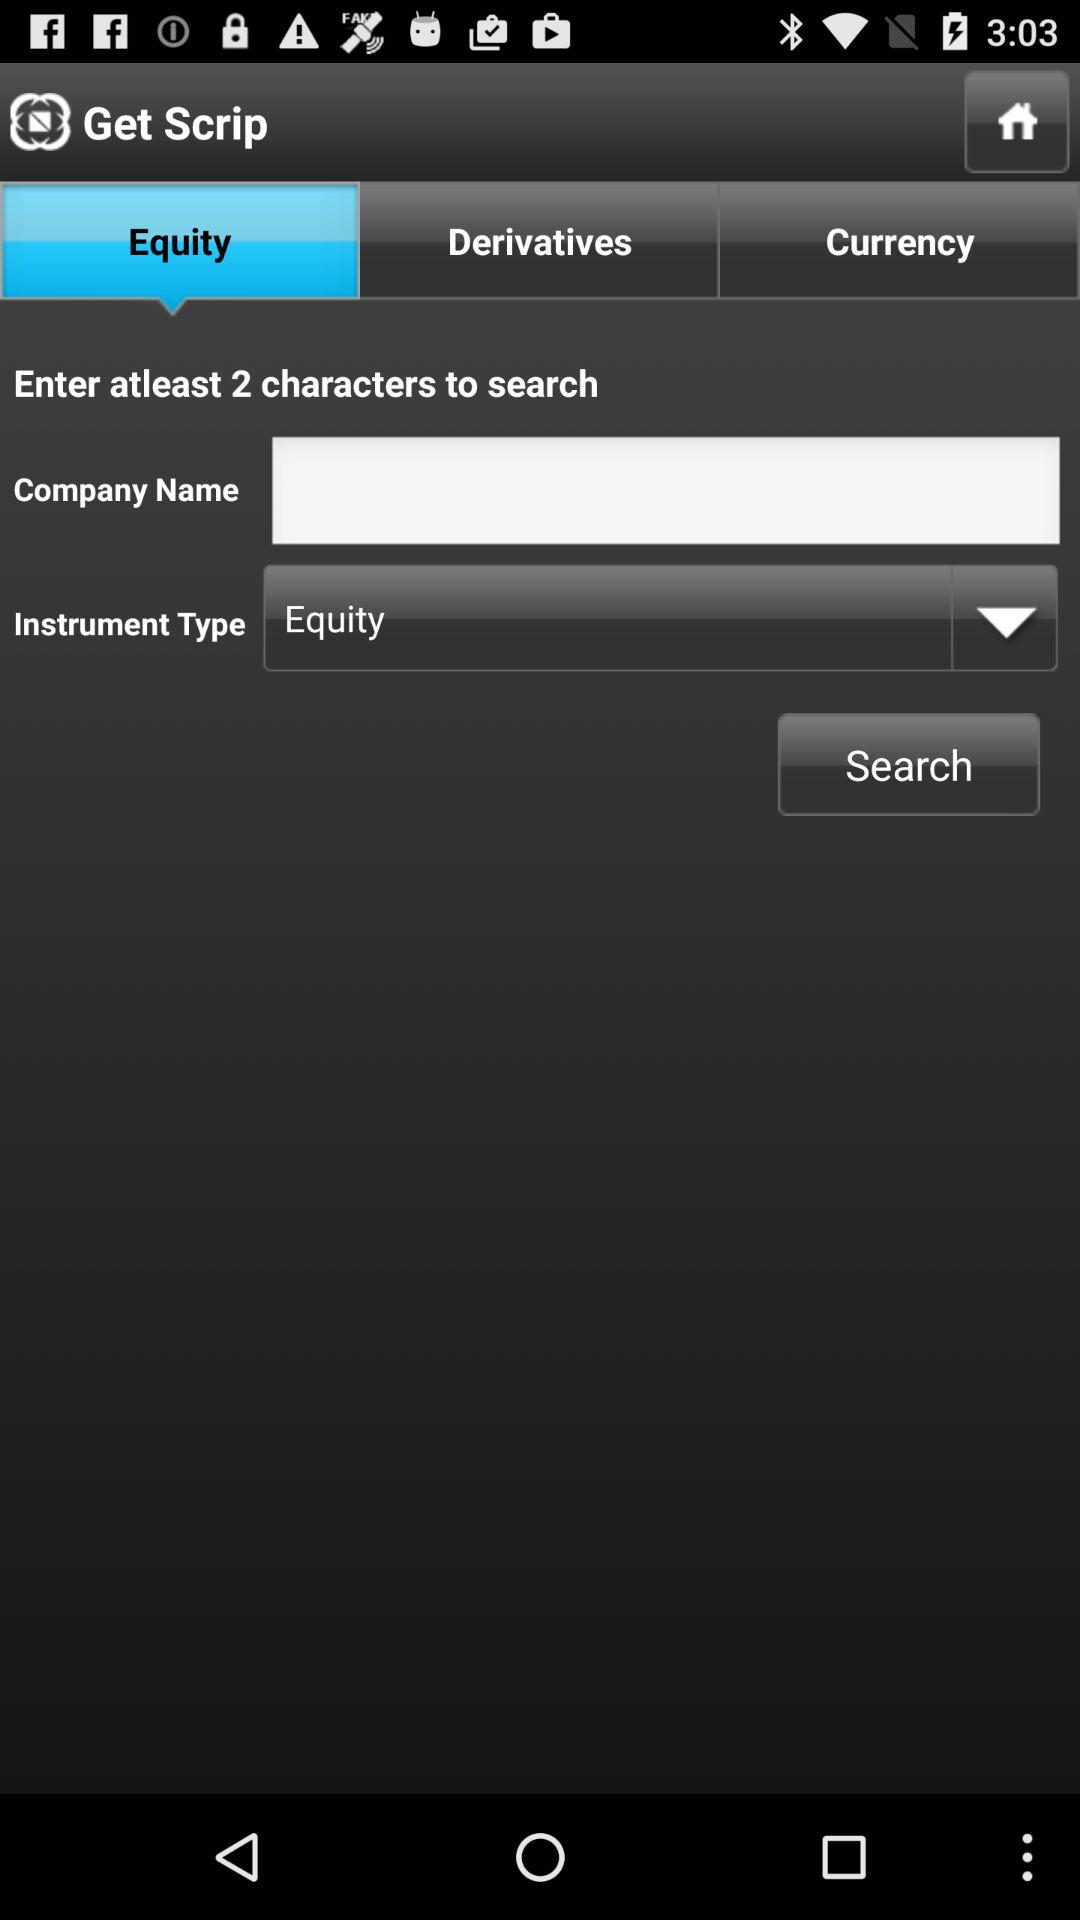Which tab is selected? The selected tab is "Equity". 